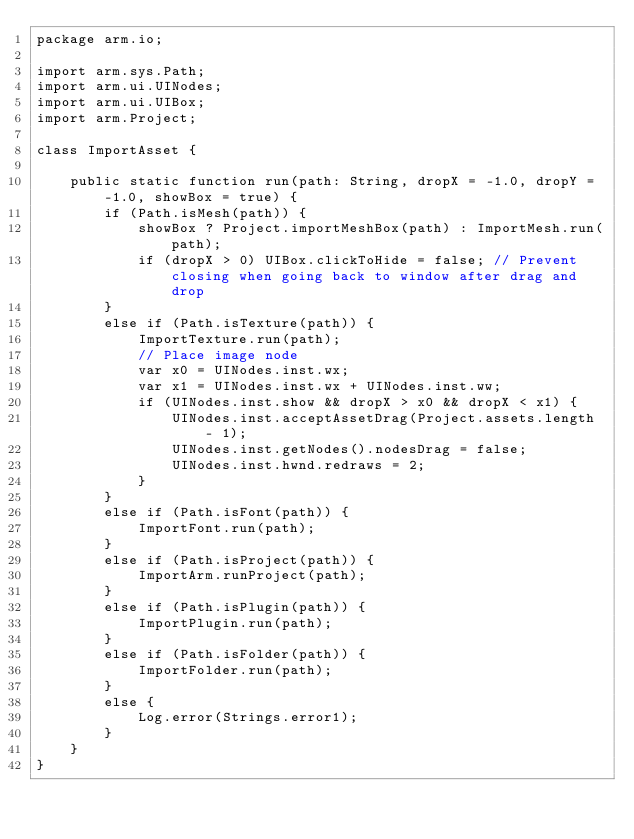Convert code to text. <code><loc_0><loc_0><loc_500><loc_500><_Haxe_>package arm.io;

import arm.sys.Path;
import arm.ui.UINodes;
import arm.ui.UIBox;
import arm.Project;

class ImportAsset {

	public static function run(path: String, dropX = -1.0, dropY = -1.0, showBox = true) {
		if (Path.isMesh(path)) {
			showBox ? Project.importMeshBox(path) : ImportMesh.run(path);
			if (dropX > 0) UIBox.clickToHide = false; // Prevent closing when going back to window after drag and drop
		}
		else if (Path.isTexture(path)) {
			ImportTexture.run(path);
			// Place image node
			var x0 = UINodes.inst.wx;
			var x1 = UINodes.inst.wx + UINodes.inst.ww;
			if (UINodes.inst.show && dropX > x0 && dropX < x1) {
				UINodes.inst.acceptAssetDrag(Project.assets.length - 1);
				UINodes.inst.getNodes().nodesDrag = false;
				UINodes.inst.hwnd.redraws = 2;
			}
		}
		else if (Path.isFont(path)) {
			ImportFont.run(path);
		}
		else if (Path.isProject(path)) {
			ImportArm.runProject(path);
		}
		else if (Path.isPlugin(path)) {
			ImportPlugin.run(path);
		}
		else if (Path.isFolder(path)) {
			ImportFolder.run(path);
		}
		else {
			Log.error(Strings.error1);
		}
	}
}
</code> 